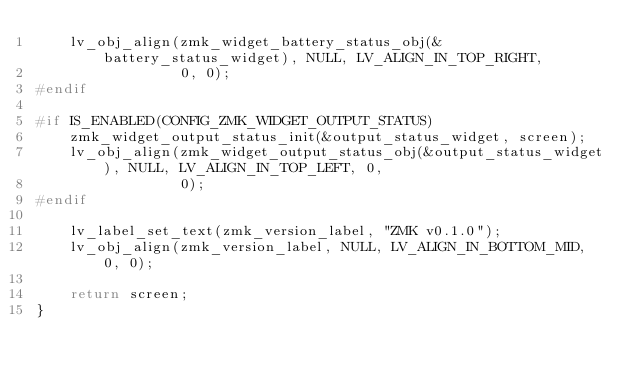<code> <loc_0><loc_0><loc_500><loc_500><_C_>    lv_obj_align(zmk_widget_battery_status_obj(&battery_status_widget), NULL, LV_ALIGN_IN_TOP_RIGHT,
                 0, 0);
#endif

#if IS_ENABLED(CONFIG_ZMK_WIDGET_OUTPUT_STATUS)
    zmk_widget_output_status_init(&output_status_widget, screen);
    lv_obj_align(zmk_widget_output_status_obj(&output_status_widget), NULL, LV_ALIGN_IN_TOP_LEFT, 0,
                 0);
#endif

    lv_label_set_text(zmk_version_label, "ZMK v0.1.0");
    lv_obj_align(zmk_version_label, NULL, LV_ALIGN_IN_BOTTOM_MID, 0, 0);

    return screen;
}
</code> 